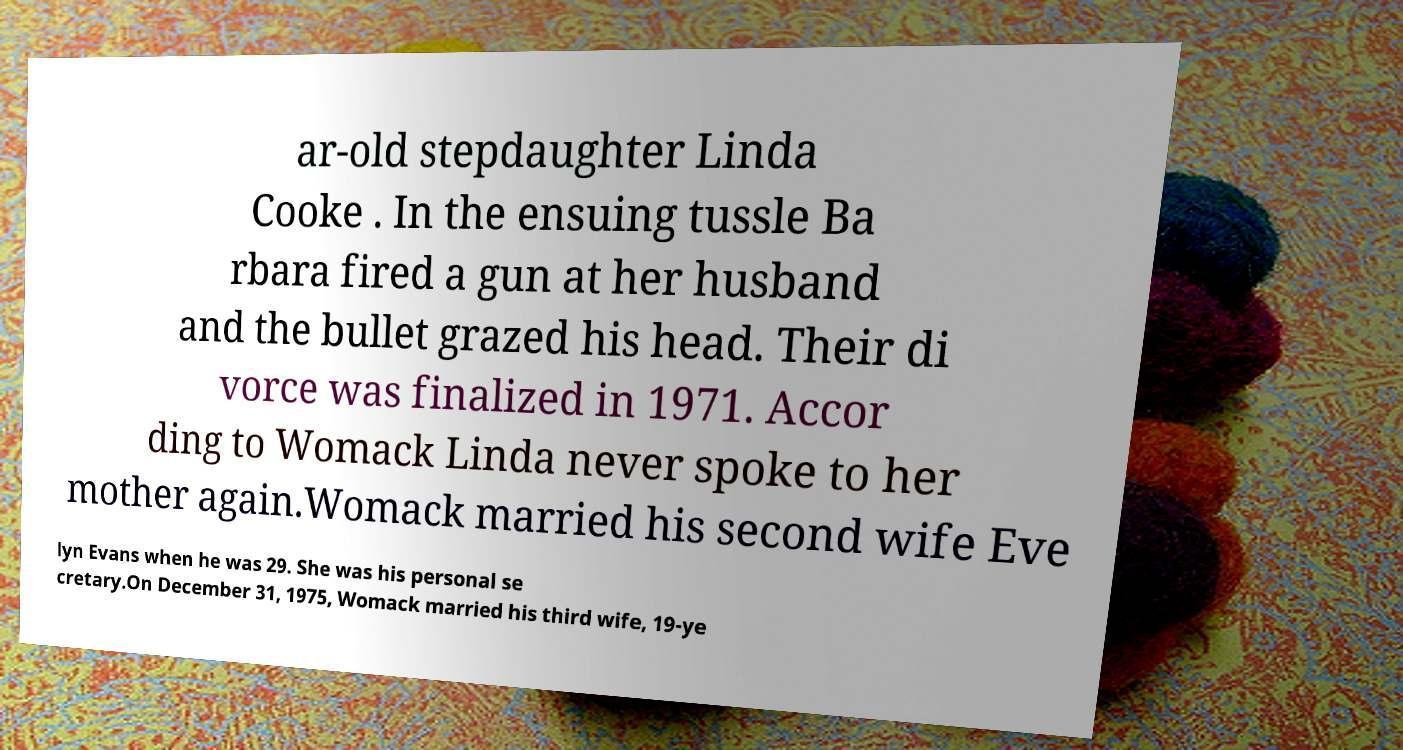Could you extract and type out the text from this image? ar-old stepdaughter Linda Cooke . In the ensuing tussle Ba rbara fired a gun at her husband and the bullet grazed his head. Their di vorce was finalized in 1971. Accor ding to Womack Linda never spoke to her mother again.Womack married his second wife Eve lyn Evans when he was 29. She was his personal se cretary.On December 31, 1975, Womack married his third wife, 19-ye 